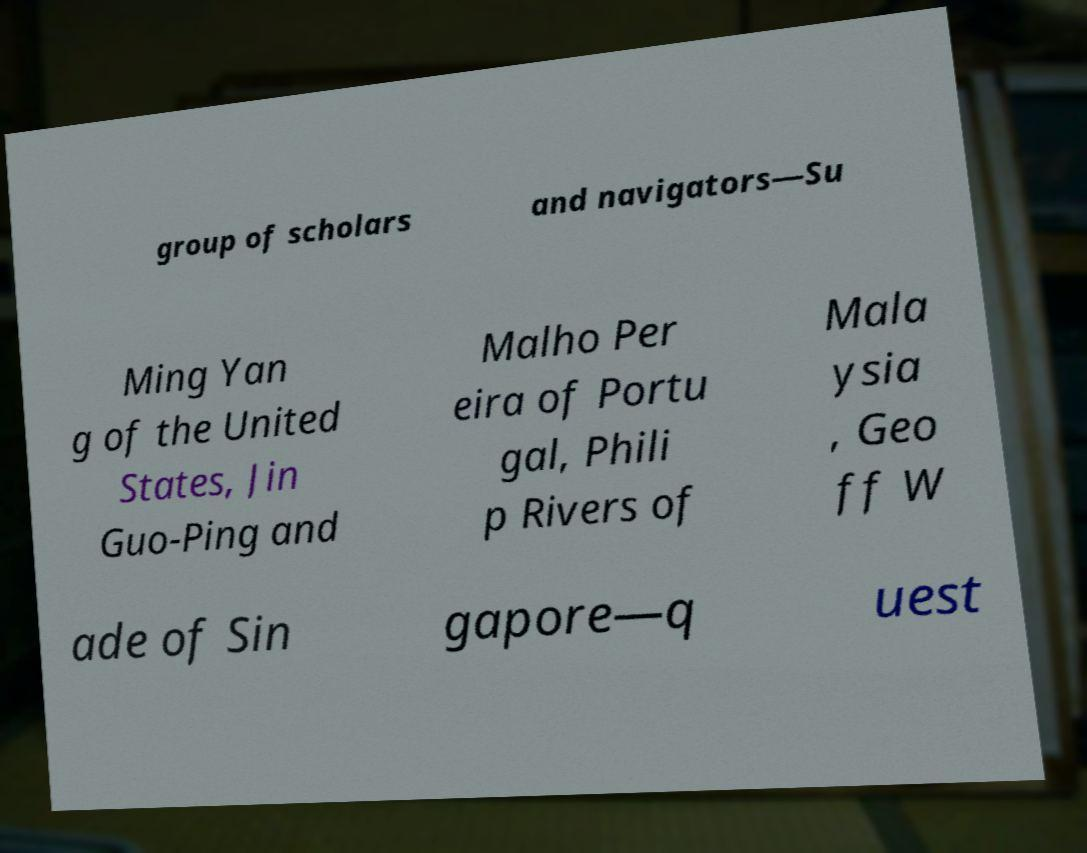Could you extract and type out the text from this image? group of scholars and navigators—Su Ming Yan g of the United States, Jin Guo-Ping and Malho Per eira of Portu gal, Phili p Rivers of Mala ysia , Geo ff W ade of Sin gapore—q uest 